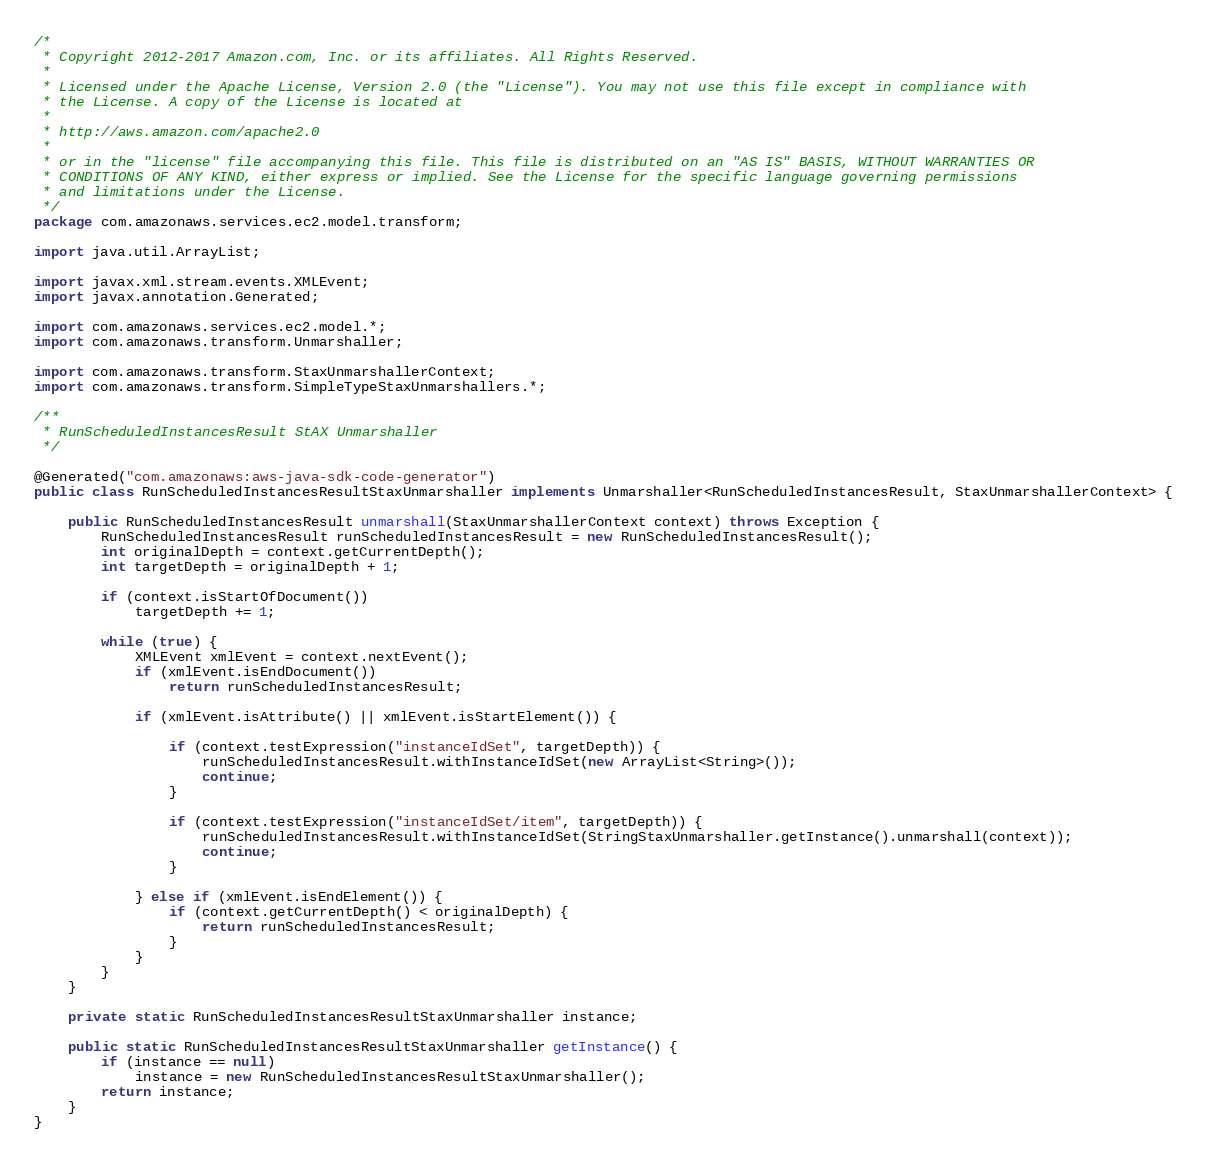<code> <loc_0><loc_0><loc_500><loc_500><_Java_>/*
 * Copyright 2012-2017 Amazon.com, Inc. or its affiliates. All Rights Reserved.
 * 
 * Licensed under the Apache License, Version 2.0 (the "License"). You may not use this file except in compliance with
 * the License. A copy of the License is located at
 * 
 * http://aws.amazon.com/apache2.0
 * 
 * or in the "license" file accompanying this file. This file is distributed on an "AS IS" BASIS, WITHOUT WARRANTIES OR
 * CONDITIONS OF ANY KIND, either express or implied. See the License for the specific language governing permissions
 * and limitations under the License.
 */
package com.amazonaws.services.ec2.model.transform;

import java.util.ArrayList;

import javax.xml.stream.events.XMLEvent;
import javax.annotation.Generated;

import com.amazonaws.services.ec2.model.*;
import com.amazonaws.transform.Unmarshaller;

import com.amazonaws.transform.StaxUnmarshallerContext;
import com.amazonaws.transform.SimpleTypeStaxUnmarshallers.*;

/**
 * RunScheduledInstancesResult StAX Unmarshaller
 */

@Generated("com.amazonaws:aws-java-sdk-code-generator")
public class RunScheduledInstancesResultStaxUnmarshaller implements Unmarshaller<RunScheduledInstancesResult, StaxUnmarshallerContext> {

    public RunScheduledInstancesResult unmarshall(StaxUnmarshallerContext context) throws Exception {
        RunScheduledInstancesResult runScheduledInstancesResult = new RunScheduledInstancesResult();
        int originalDepth = context.getCurrentDepth();
        int targetDepth = originalDepth + 1;

        if (context.isStartOfDocument())
            targetDepth += 1;

        while (true) {
            XMLEvent xmlEvent = context.nextEvent();
            if (xmlEvent.isEndDocument())
                return runScheduledInstancesResult;

            if (xmlEvent.isAttribute() || xmlEvent.isStartElement()) {

                if (context.testExpression("instanceIdSet", targetDepth)) {
                    runScheduledInstancesResult.withInstanceIdSet(new ArrayList<String>());
                    continue;
                }

                if (context.testExpression("instanceIdSet/item", targetDepth)) {
                    runScheduledInstancesResult.withInstanceIdSet(StringStaxUnmarshaller.getInstance().unmarshall(context));
                    continue;
                }

            } else if (xmlEvent.isEndElement()) {
                if (context.getCurrentDepth() < originalDepth) {
                    return runScheduledInstancesResult;
                }
            }
        }
    }

    private static RunScheduledInstancesResultStaxUnmarshaller instance;

    public static RunScheduledInstancesResultStaxUnmarshaller getInstance() {
        if (instance == null)
            instance = new RunScheduledInstancesResultStaxUnmarshaller();
        return instance;
    }
}
</code> 